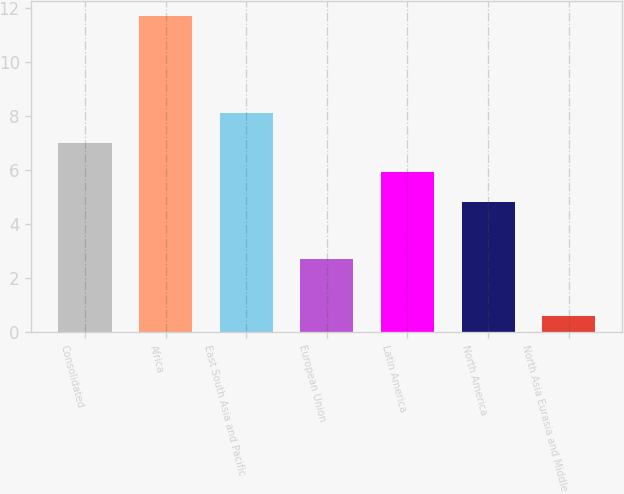Convert chart. <chart><loc_0><loc_0><loc_500><loc_500><bar_chart><fcel>Consolidated<fcel>Africa<fcel>East South Asia and Pacific<fcel>European Union<fcel>Latin America<fcel>North America<fcel>North Asia Eurasia and Middle<nl><fcel>7.02<fcel>11.7<fcel>8.13<fcel>2.7<fcel>5.91<fcel>4.8<fcel>0.6<nl></chart> 